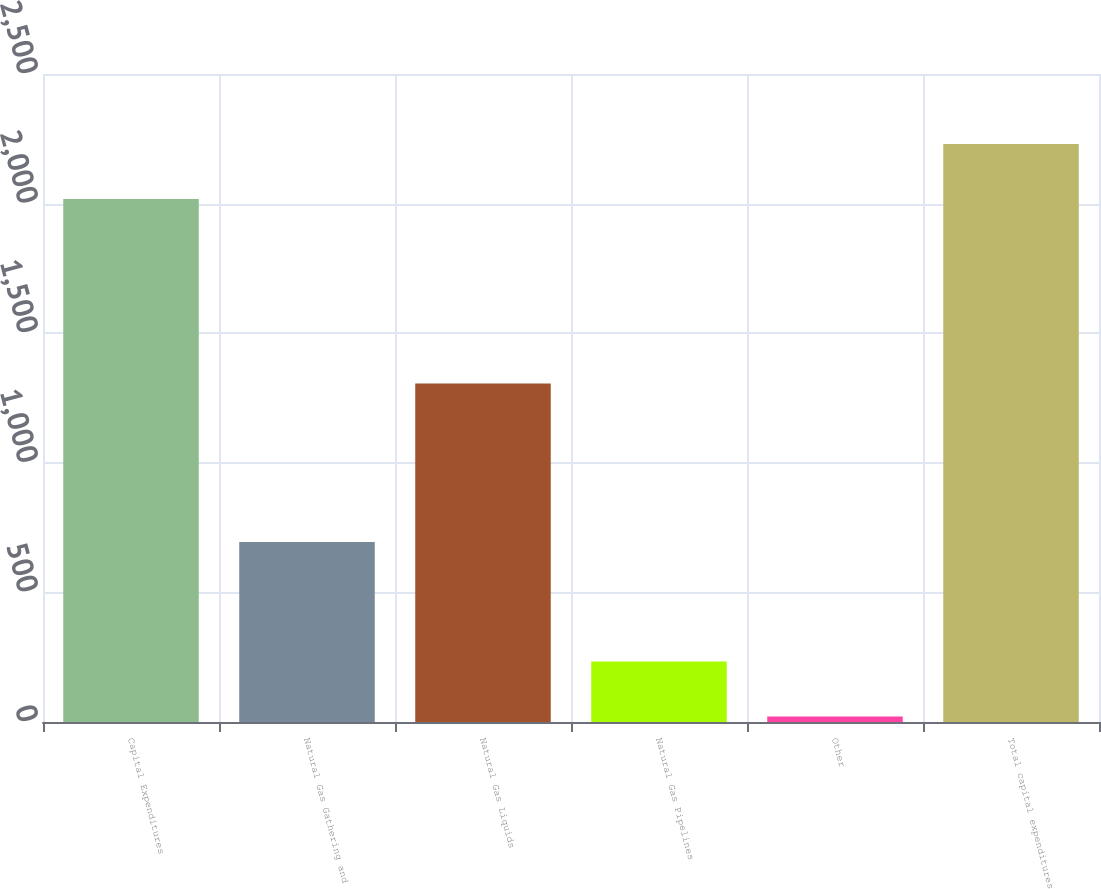Convert chart to OTSL. <chart><loc_0><loc_0><loc_500><loc_500><bar_chart><fcel>Capital Expenditures<fcel>Natural Gas Gathering and<fcel>Natural Gas Liquids<fcel>Natural Gas Pipelines<fcel>Other<fcel>Total capital expenditures<nl><fcel>2018<fcel>694.6<fcel>1306.3<fcel>233.41<fcel>21.4<fcel>2230.01<nl></chart> 